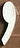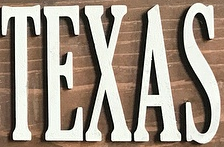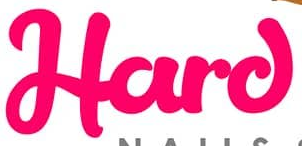What text is displayed in these images sequentially, separated by a semicolon? ,; TEXAS; Hard 